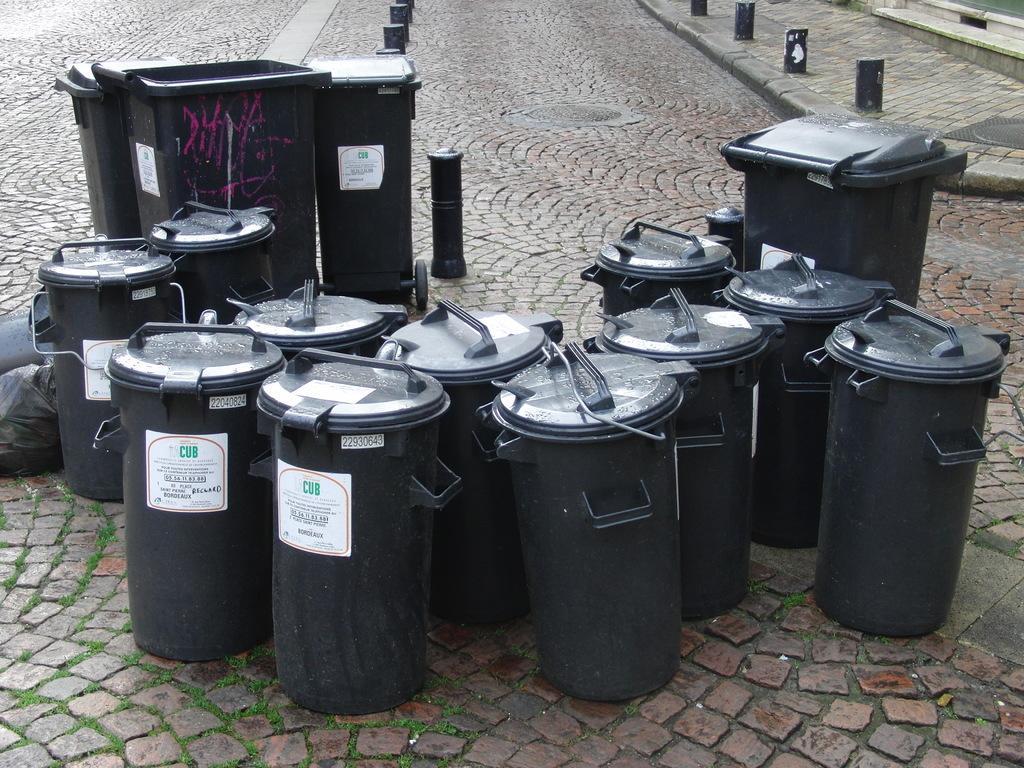Could you give a brief overview of what you see in this image? In the picture I can see many black color baskets, trash cans and trash covers are placed on the road. 